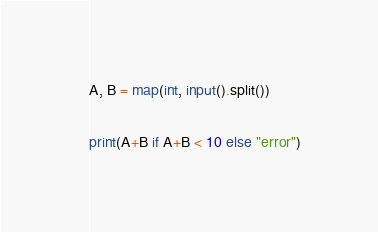Convert code to text. <code><loc_0><loc_0><loc_500><loc_500><_Python_>A, B = map(int, input().split())

print(A+B if A+B < 10 else "error")
</code> 